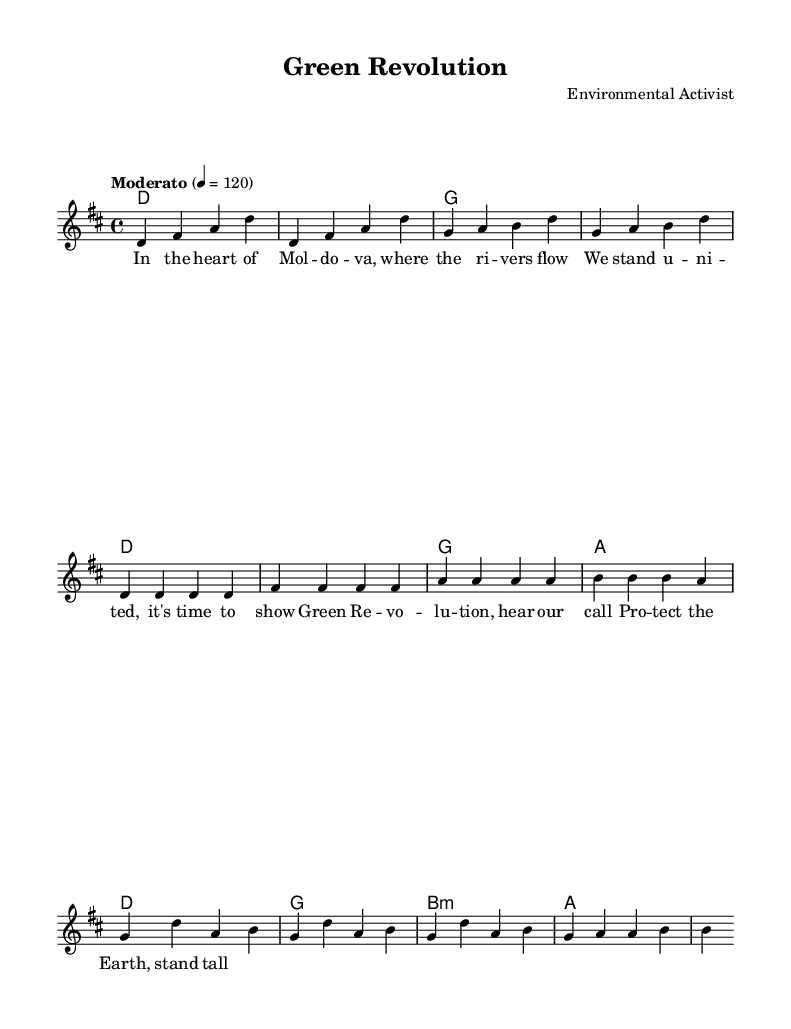What is the key signature of this music? The key signature is D major, which has two sharps (F# and C#). This can be identified at the beginning of the staff where the sharps are placed.
Answer: D major What is the time signature of this piece? The time signature is 4/4, which indicates that there are four beats in each measure. This is visible at the beginning of the score following the clef indication.
Answer: 4/4 What is the tempo marking given for this song? The tempo marking is "Moderato" at a speed of 120 beats per minute, which is indicated just below the time signature.
Answer: Moderato, 120 How many measures are in the intro section? The intro consists of 4 measures, as can be seen from the grouping of the notes before the verse starts.
Answer: 4 What is the main theme of the lyrics in the verse? The main theme in the verse focuses on unity and action regarding environmental issues in Moldova, as represented by the specific lyrics provided.
Answer: Unity and action What chord progression is used in the chorus? The chord progression in the chorus moves from D to G to B minor to A, which can be identified in the harmonic notation for that section.
Answer: D, G, B minor, A How does the melody relate to the lyrics in the chorus? The melody follows a repetitive pattern that matches the rhythm and emphasis of the lyrics in the chorus, enhancing the call to action in the song.
Answer: Repetitive and enhancing 